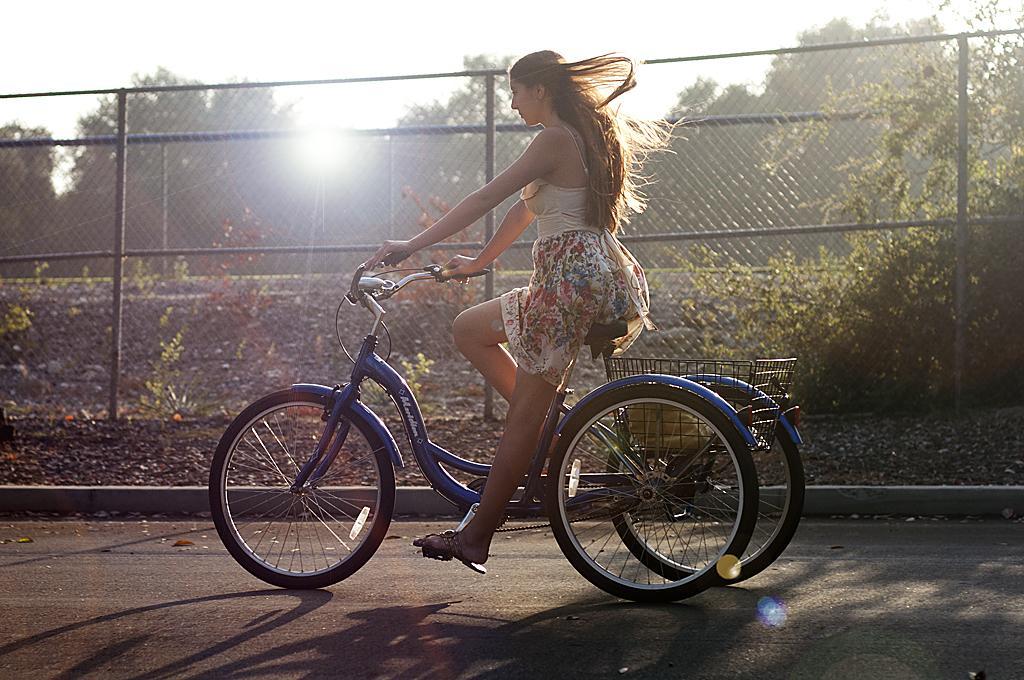How would you summarize this image in a sentence or two? In this image i can see a woman riding a bicycle. In the background i can see a metal fence, trees, sky and sun. 